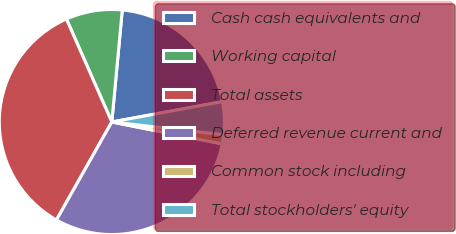Convert chart to OTSL. <chart><loc_0><loc_0><loc_500><loc_500><pie_chart><fcel>Cash cash equivalents and<fcel>Working capital<fcel>Total assets<fcel>Deferred revenue current and<fcel>Common stock including<fcel>Total stockholders' equity<nl><fcel>20.62%<fcel>8.09%<fcel>35.2%<fcel>30.07%<fcel>1.32%<fcel>4.7%<nl></chart> 